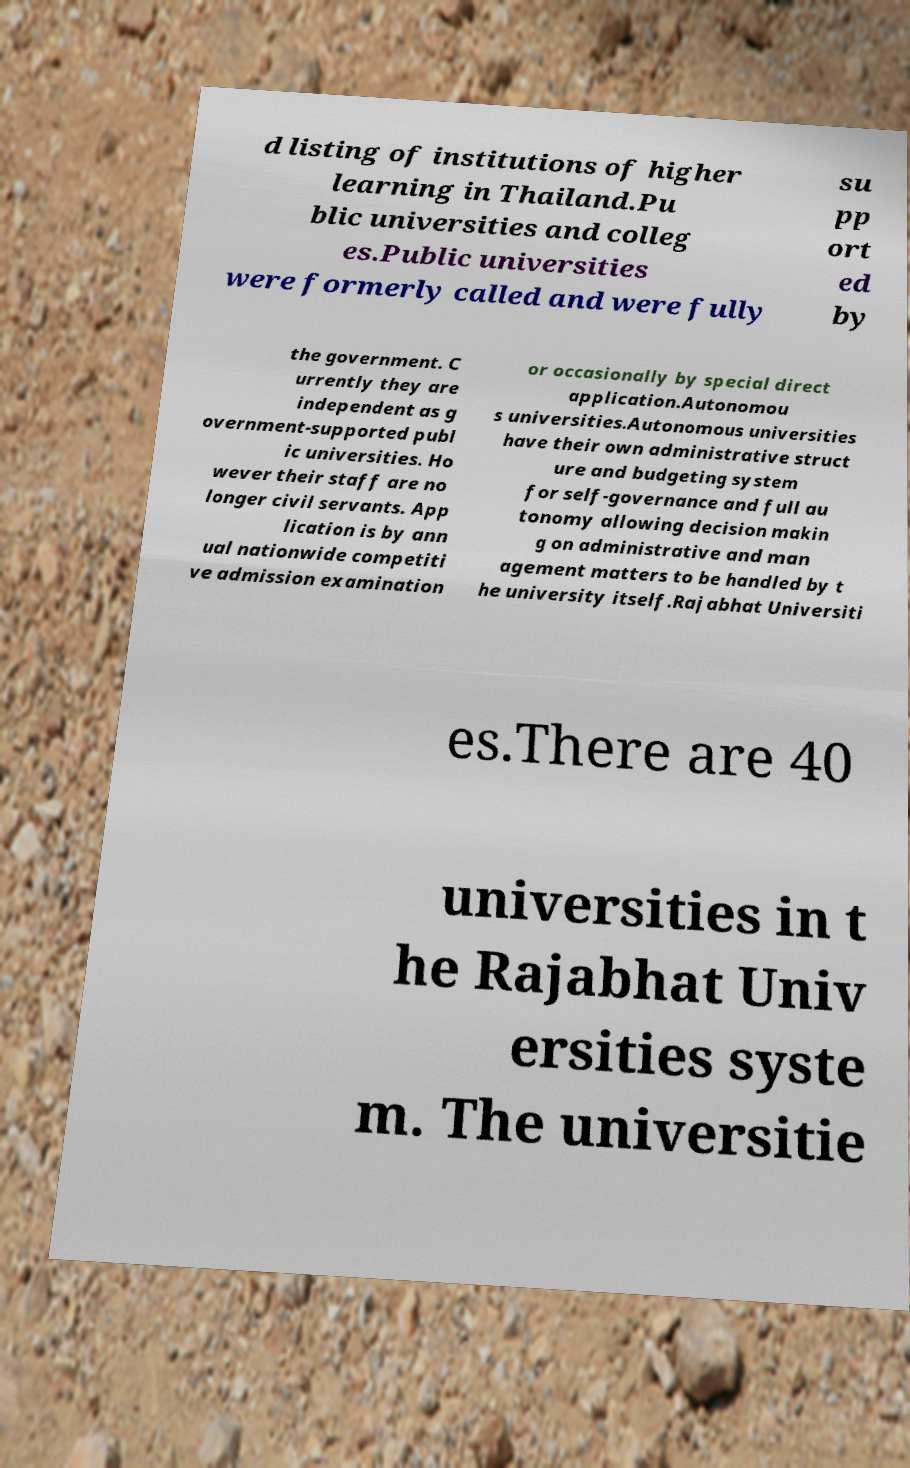Could you assist in decoding the text presented in this image and type it out clearly? d listing of institutions of higher learning in Thailand.Pu blic universities and colleg es.Public universities were formerly called and were fully su pp ort ed by the government. C urrently they are independent as g overnment-supported publ ic universities. Ho wever their staff are no longer civil servants. App lication is by ann ual nationwide competiti ve admission examination or occasionally by special direct application.Autonomou s universities.Autonomous universities have their own administrative struct ure and budgeting system for self-governance and full au tonomy allowing decision makin g on administrative and man agement matters to be handled by t he university itself.Rajabhat Universiti es.There are 40 universities in t he Rajabhat Univ ersities syste m. The universitie 